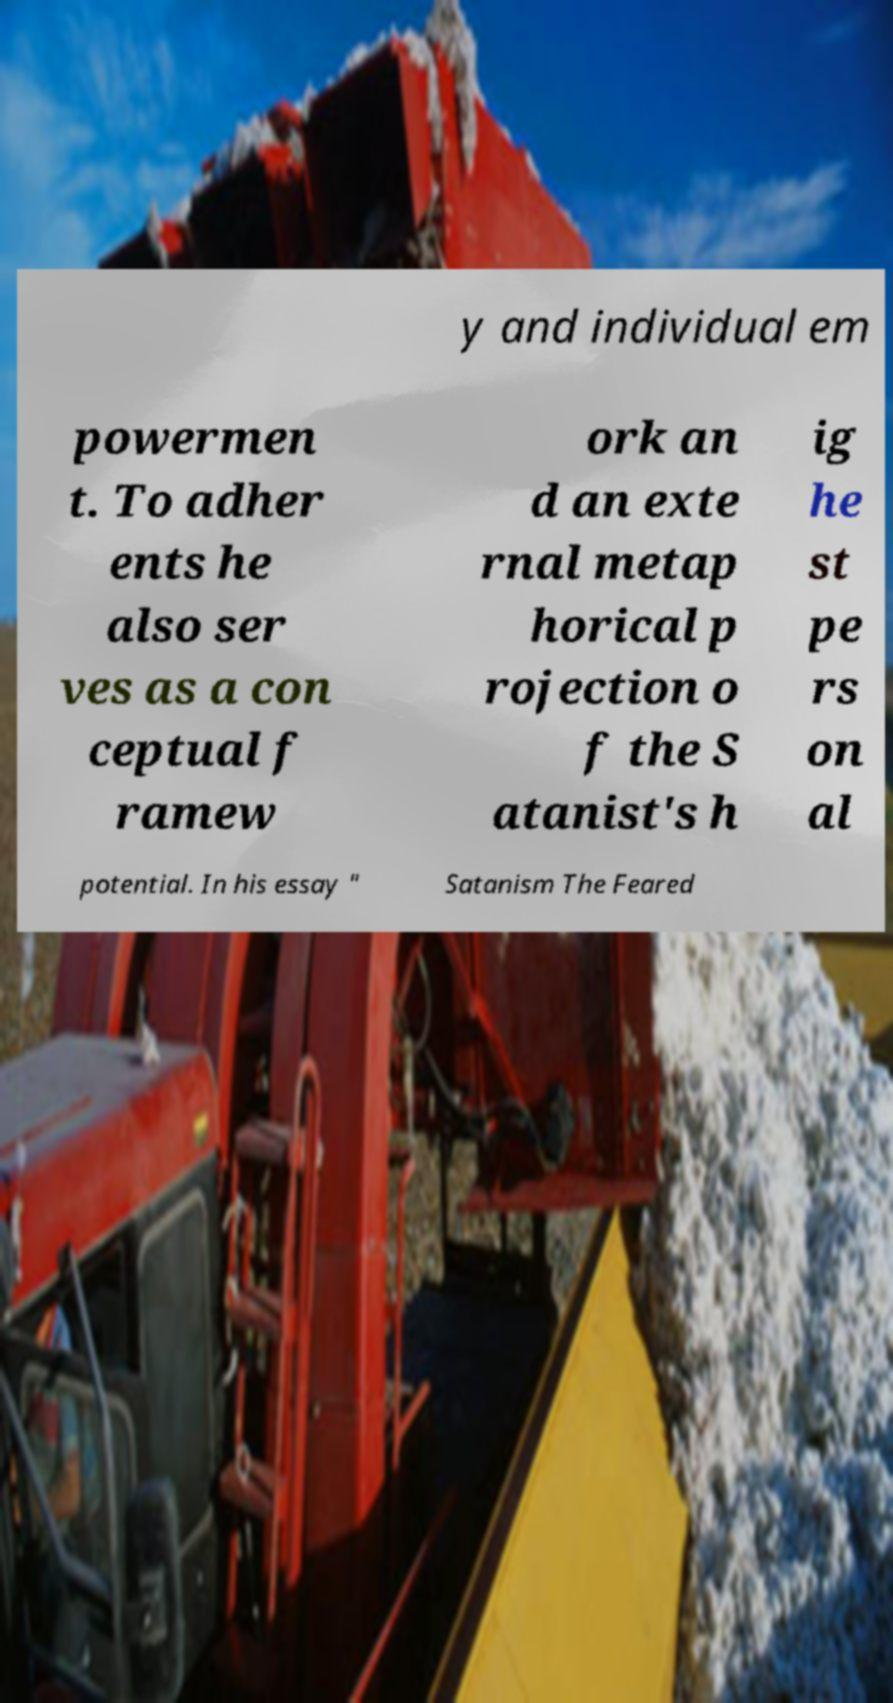Please read and relay the text visible in this image. What does it say? y and individual em powermen t. To adher ents he also ser ves as a con ceptual f ramew ork an d an exte rnal metap horical p rojection o f the S atanist's h ig he st pe rs on al potential. In his essay " Satanism The Feared 